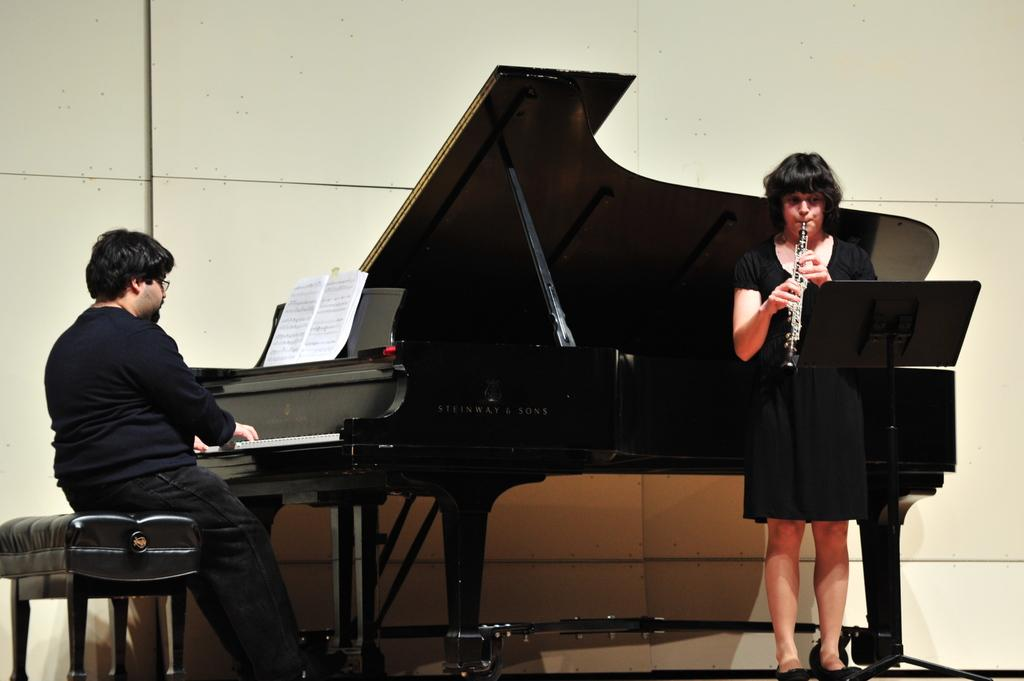What is the woman in the image doing? The woman is playing a trumpet in the image. Where is the woman located in the image? The woman is on the right side of the image. What is the woman wearing? The woman is wearing a black dress. What is the man in the image doing? The man is playing a piano in the image. Where is the man located in the image? The man is on the left side of the image. What is visible in the background of the image? There is a wall visible in the image. What type of curve can be seen on the woman's teeth in the image? There is no curve on the woman's teeth visible in the image, as her mouth is not open and no teeth are shown. 